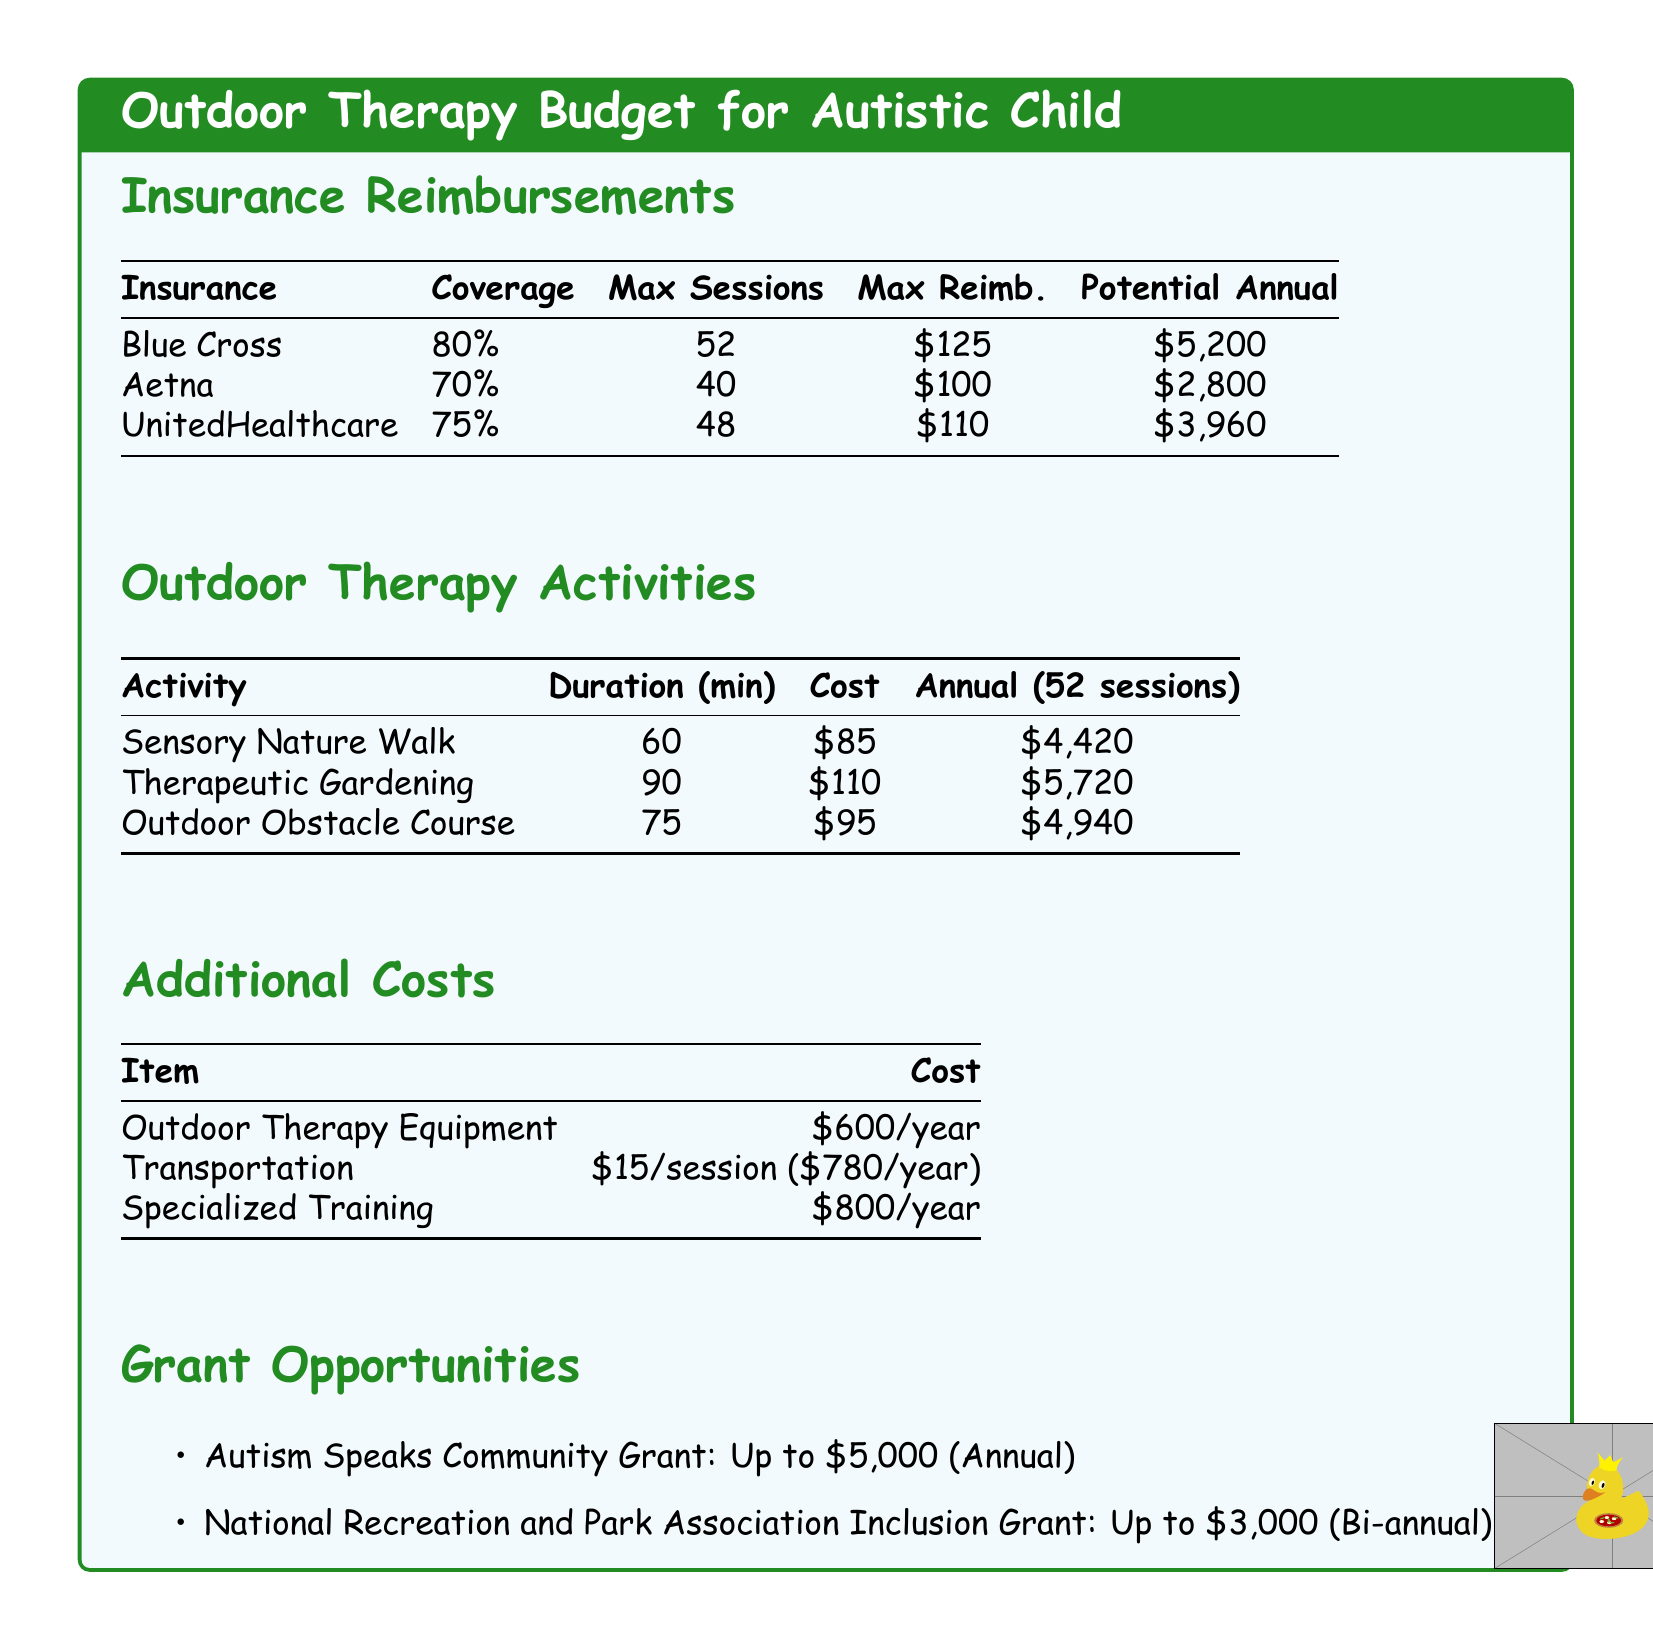What is the coverage percentage for Blue Cross? The document states the coverage for Blue Cross is 80%.
Answer: 80% How much is the maximum reimbursement for UnitedHealthcare? The document lists the maximum reimbursement for UnitedHealthcare as $110.
Answer: $110 What is the potential annual reimbursement from Aetna? The potential annual reimbursement from Aetna is mentioned as $2,800.
Answer: $2,800 What is the cost of a Sensory Nature Walk? The document specifies the cost of a Sensory Nature Walk as $85.
Answer: $85 How many maximum sessions does Aetna cover? The maximum sessions covered by Aetna is stated as 40.
Answer: 40 Which activity has the highest annual cost? Therapeutic Gardening has the highest annual cost, detailed as $5,720.
Answer: $5,720 What is the total cost for transportation for a year? The total cost for transportation is calculated as $15 per session for a total of 52 sessions, amounting to $780.
Answer: $780 What is the total additional cost for outdoor therapy equipment? The document mentions the cost for outdoor therapy equipment as $600 per year.
Answer: $600 What grant offers up to $5,000 annually? The Autism Speaks Community Grant offers up to $5,000 annually.
Answer: Autism Speaks Community Grant 